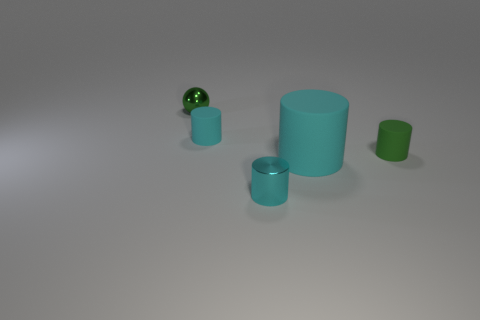There is a metallic object on the right side of the small sphere; does it have the same color as the large matte object?
Your answer should be compact. Yes. There is a cylinder behind the green thing that is on the right side of the small green metallic object; is there a tiny green cylinder behind it?
Provide a short and direct response. No. What number of green objects are in front of the green ball?
Your response must be concise. 1. What number of large rubber objects have the same color as the large matte cylinder?
Make the answer very short. 0. How many things are small green things that are in front of the green ball or matte cylinders that are to the right of the big thing?
Your answer should be very brief. 1. Are there more green cylinders than cyan shiny blocks?
Provide a succinct answer. Yes. The metal thing that is behind the tiny cyan shiny cylinder is what color?
Offer a very short reply. Green. Is the big cyan matte thing the same shape as the green metal thing?
Provide a succinct answer. No. What color is the small object that is left of the metallic cylinder and in front of the shiny ball?
Your response must be concise. Cyan. There is a green thing that is to the right of the sphere; is it the same size as the green object on the left side of the large cyan matte cylinder?
Give a very brief answer. Yes. 